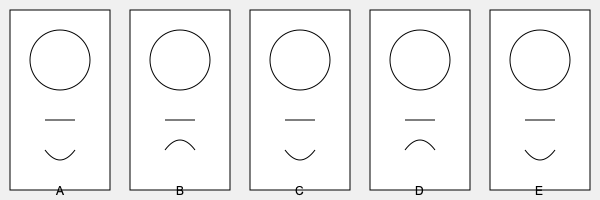A witness has described the suspect as having a prominent scar on their right cheek and a frowning expression. Based on the lineup of facial sketches provided, which suspect (A, B, C, D, or E) most closely matches this description? To identify the suspect that most closely matches the witness description, let's analyze each sketch:

1. Suspect A:
   - No visible scar
   - Neutral expression (straight line for mouth)

2. Suspect B:
   - No visible scar
   - Smiling expression (curved up mouth)

3. Suspect C:
   - No visible scar
   - Frowning expression (curved down mouth)

4. Suspect D:
   - Visible line on the right side of the face, which could represent a scar
   - Smiling expression (curved up mouth)

5. Suspect E:
   - Visible line on the right side of the face, which could represent a scar
   - Frowning expression (curved down mouth)

The witness described two key features:
1. A prominent scar on the right cheek
2. A frowning expression

Suspect E is the only one that matches both criteria: the line on the right side of the face could represent a scar, and the mouth is curved downward, indicating a frowning expression.
Answer: E 